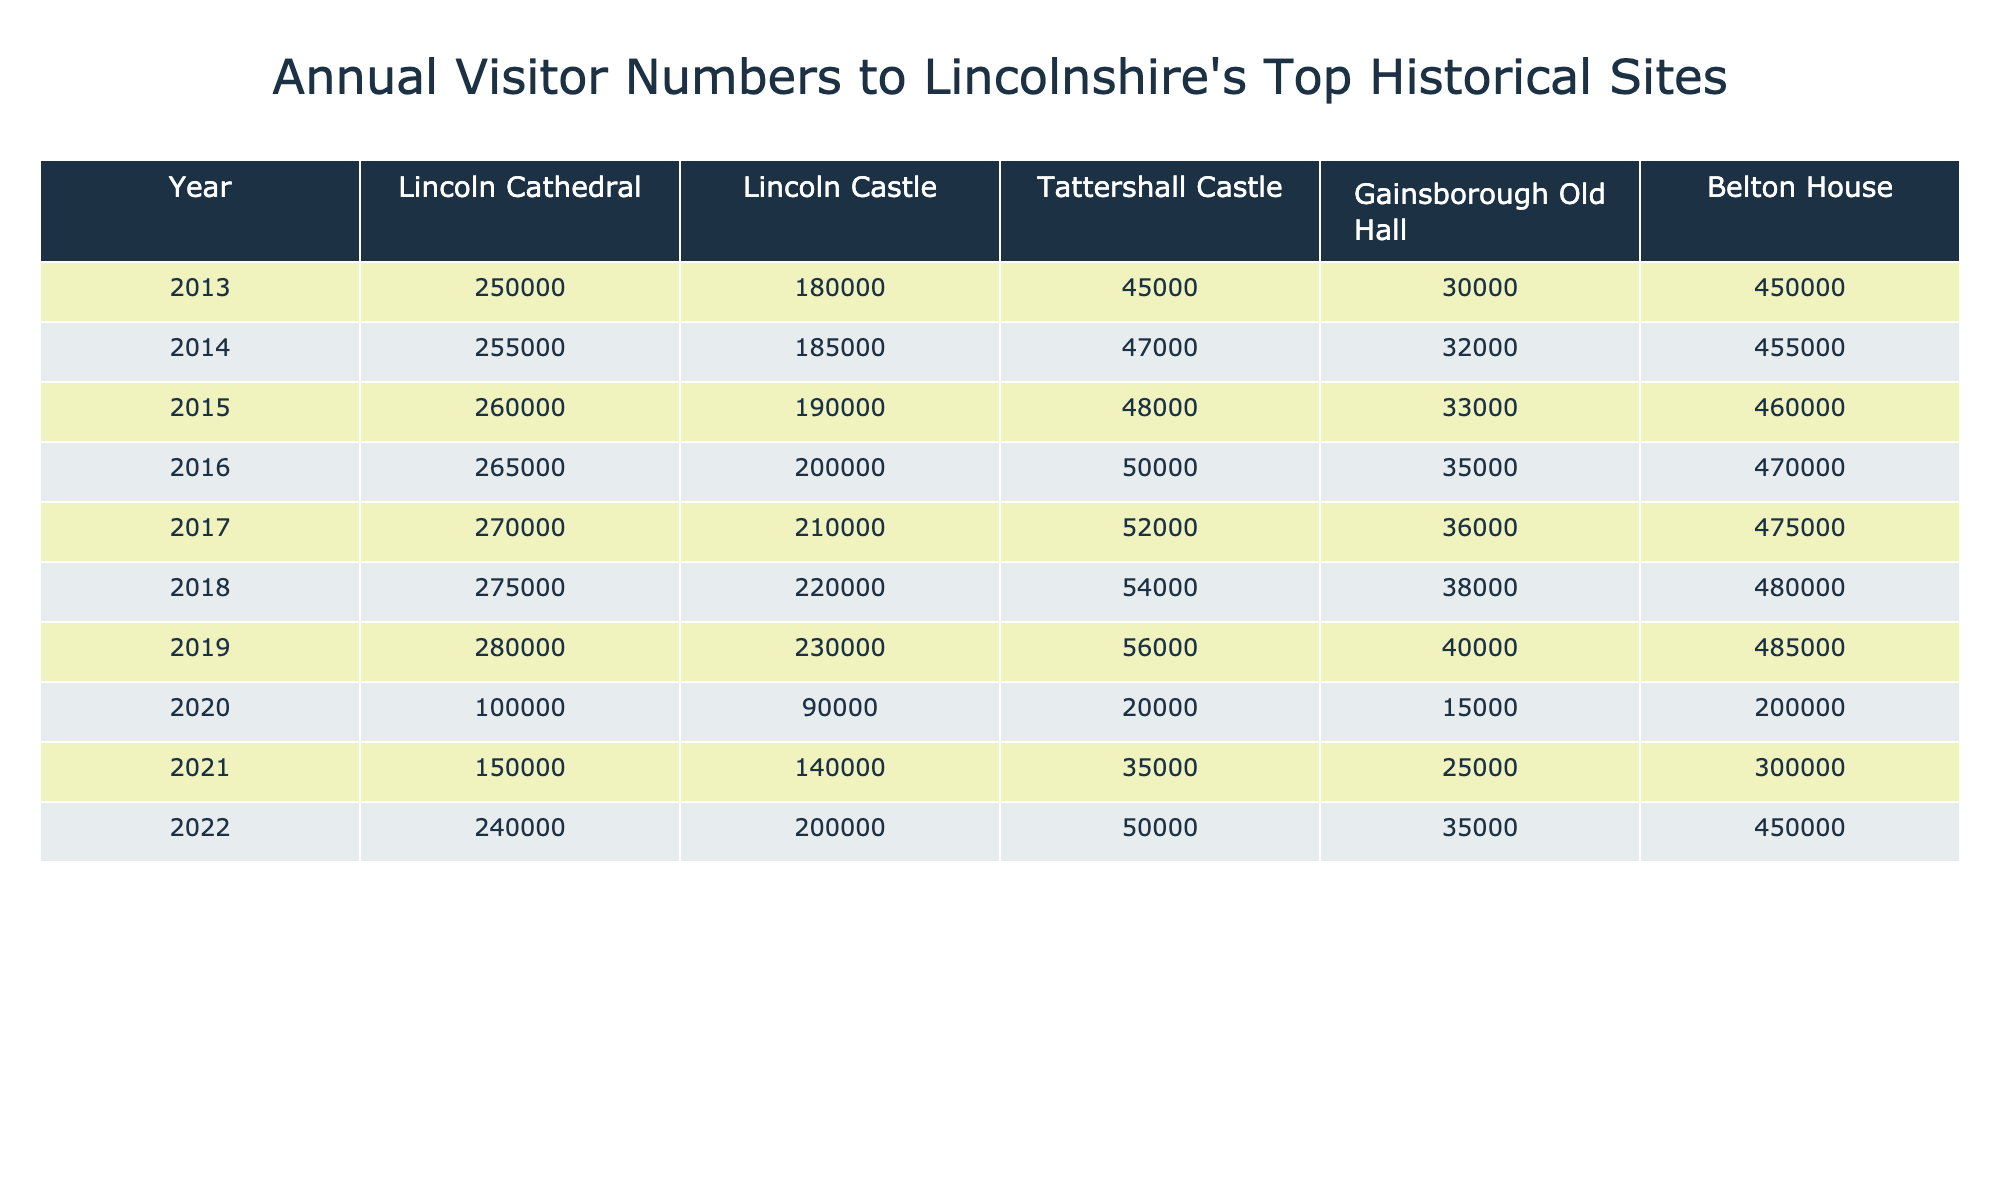What was the visitor number to Lincoln Cathedral in 2015? According to the table, in the year 2015, the visitor number to Lincoln Cathedral is specifically listed as 260,000.
Answer: 260,000 What is the total number of visitors to all sites in 2019? To find the total for 2019, I sum the visitors: Lincoln Cathedral (280,000) + Lincoln Castle (230,000) + Tattershall Castle (56,000) + Gainsborough Old Hall (40,000) + Belton House (485,000) = 1,091,000.
Answer: 1,091,000 How many more visitors did Lincoln Castle receive than Gainsborough Old Hall in 2017? In 2017, Lincoln Castle had 210,000 visitors and Gainsborough Old Hall had 36,000 visitors. The difference is calculated as 210,000 - 36,000 = 174,000.
Answer: 174,000 What is the average annual visitor count for Tattershall Castle over the decade? The visitor numbers for Tattershall Castle from 2013 to 2022 are 45,000, 47,000, 48,000, 50,000, 52,000, 54,000, 56,000, 20,000, 35,000, and 50,000. To find the average: (45,000 + 47,000 + 48,000 + 50,000 + 52,000 + 54,000 + 56,000 + 20,000 + 35,000 + 50,000) / 10 = 45,700.
Answer: 45,700 Has the visitor count for Belton House increased every year from 2013 to 2022? By looking at the table, I see that the numbers for Belton House increased from 450,000 in 2013 to 455,000 in 2014, then continued to rise until a dip in 2020 to 200,000. The count then increased to 300,000 in 2021 and to 450,000 in 2022. Since there was a decrease in 2020, the claim is false.
Answer: No Which site had the highest visitor growth from 2021 to 2022? I compare the visitor numbers for each site between 2021 and 2022: Lincoln Cathedral: 150,000 to 240,000 (90,000 increase), Lincoln Castle: 140,000 to 200,000 (60,000 increase), Tattershall Castle: 35,000 to 50,000 (15,000 increase), Gainsborough Old Hall: 25,000 to 35,000 (10,000 increase), Belton House: 300,000 to 450,000 (150,000 increase). The highest growth is for Belton House with an increase of 150,000 visitors.
Answer: Belton House What was the percentage drop in visitors to Lincoln Cathedral from 2019 to 2020? Lincoln Cathedral had 280,000 visitors in 2019 and 100,000 in 2020. The drop is 280,000 - 100,000 = 180,000. To find the percentage drop: (180,000 / 280,000) * 100 = 64.29%.
Answer: 64.29% In which year did Gainsborough Old Hall have its lowest visitor number? By examining the list for Gainsborough Old Hall, the lowest visitor number is seen in 2020 with only 15,000 visitors. Other years have higher figures, confirming that 2020 is indeed the lowest.
Answer: 2020 